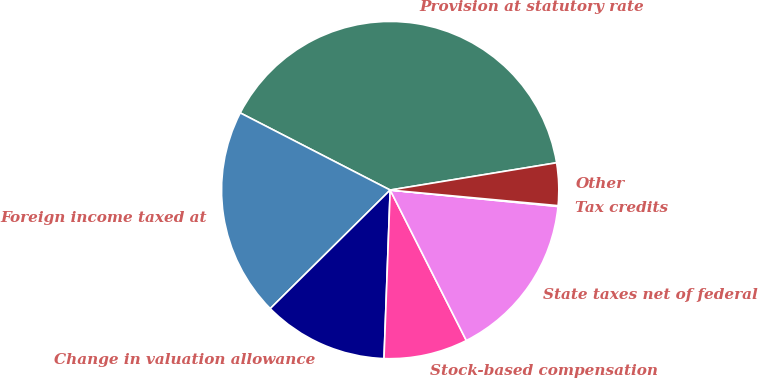Convert chart to OTSL. <chart><loc_0><loc_0><loc_500><loc_500><pie_chart><fcel>Provision at statutory rate<fcel>Foreign income taxed at<fcel>Change in valuation allowance<fcel>Stock-based compensation<fcel>State taxes net of federal<fcel>Tax credits<fcel>Other<nl><fcel>39.85%<fcel>19.97%<fcel>12.01%<fcel>8.04%<fcel>15.99%<fcel>0.08%<fcel>4.06%<nl></chart> 